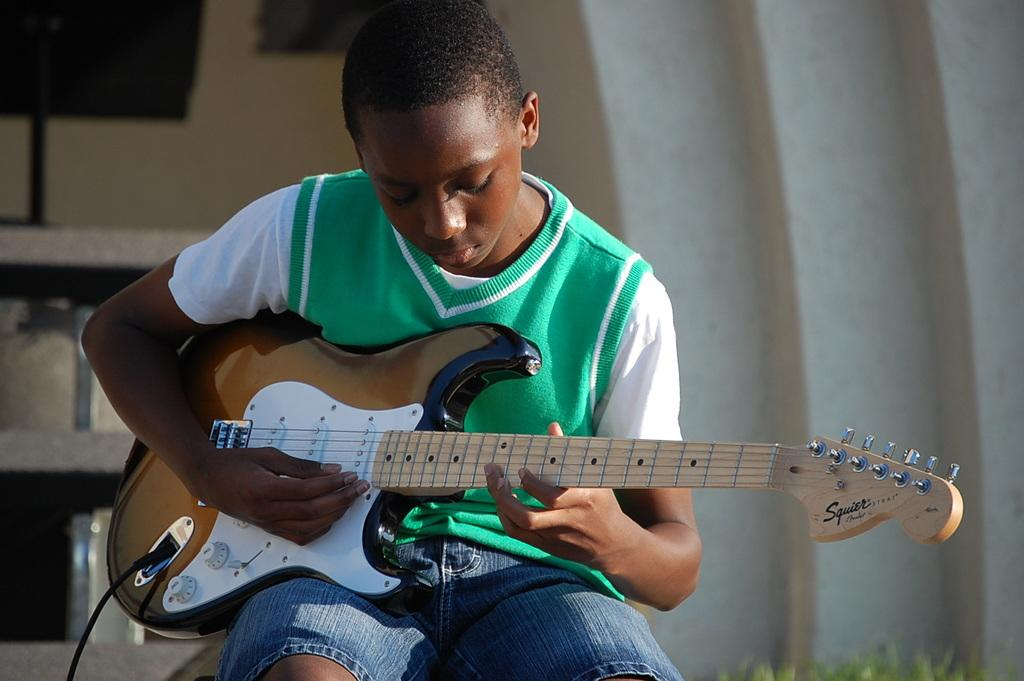What is the main subject of the image? The main subject of the image is a boy. What is the boy doing in the image? The boy is sitting in the image. What object is the boy holding? The boy is holding a guitar. What type of floor can be seen in the image? There is no floor visible in the image; it only shows the boy sitting and holding a guitar. Is the boy driving a vehicle in the image? No, the boy is not driving a vehicle in the image; he is sitting and holding a guitar. 